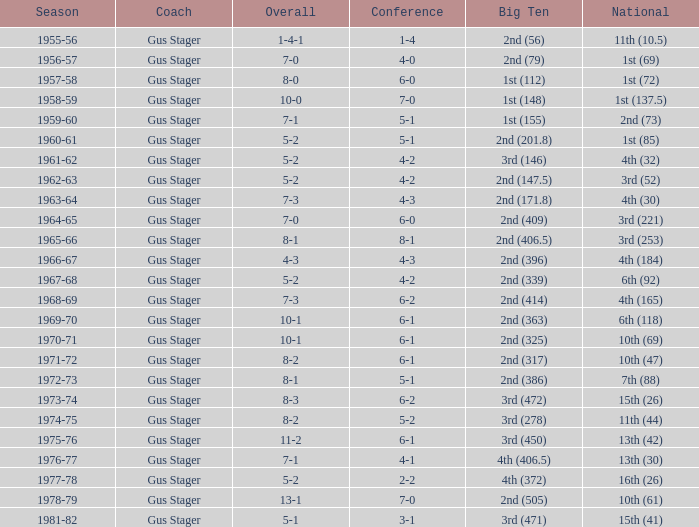What is the Coach with a Big Ten that is 2nd (79)? Gus Stager. 